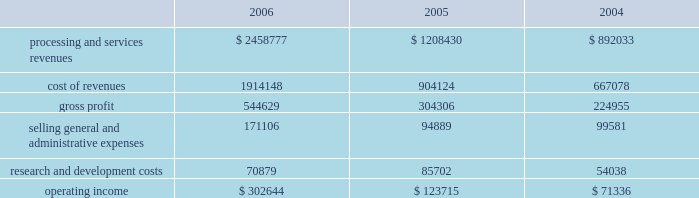Higher average borrowings .
Additionally , the recapitalization that occurred late in the first quarter of 2005 resulted in a full year of interest in 2006 as compared to approximately ten months in 2005 .
The increase in interest expense in 2005 as compared to 2004 also resulted from the recapitalization in 2005 .
Income tax expense income tax expense totaled $ 150.2 million , $ 116.1 million and $ 118.3 million for 2006 , 2005 and 2004 , respectively .
This resulted in an effective tax rate of 37.2% ( 37.2 % ) , 37.2% ( 37.2 % ) and 37.6% ( 37.6 % ) for 2006 , 2005 and 2004 , respectively .
Net earnings net earnings totaled $ 259.1 million , $ 196.6 and $ 189.4 million for 2006 , 2005 and 2004 , respectively , or $ 1.37 , $ 1.53 and $ 1.48 per diluted share , respectively .
Segment results of operations transaction processing services ( in thousands ) .
Revenues for the transaction processing services segment are derived from three main revenue channels ; enterprise solutions , integrated financial solutions and international .
Revenues from transaction processing services totaled $ 2458.8 million , $ 1208.4 and $ 892.0 million for 2006 , 2005 and 2004 , respectively .
The overall segment increase of $ 1250.4 million during 2006 , as compared to 2005 was primarily attributable to the certegy merger which contributed $ 1067.2 million to the overall increase .
The majority of the remaining 2006 growth is attributable to organic growth within the historically owned integrated financial solutions and international revenue channels , with international including $ 31.9 million related to the newly formed business process outsourcing operation in brazil .
The overall segment increase of $ 316.4 in 2005 as compared to 2004 results from the inclusion of a full year of results for the 2004 acquisitions of aurum , sanchez , kordoba , and intercept , which contributed $ 301.1 million of the increase .
Cost of revenues for the transaction processing services segment totaled $ 1914.1 million , $ 904.1 million and $ 667.1 million for 2006 , 2005 and 2004 , respectively .
The overall segment increase of $ 1010.0 million during 2006 as compared to 2005 was primarily attributable to the certegy merger which contributed $ 848.2 million to the increase .
Gross profit as a percentage of revenues ( 201cgross margin 201d ) was 22.2% ( 22.2 % ) , 25.2% ( 25.2 % ) and 25.2% ( 25.2 % ) for 2006 , 2005 and 2004 , respectively .
The decrease in gross profit in 2006 as compared to 2005 is primarily due to the february 1 , 2006 certegy merger , which businesses typically have lower margins than those of the historically owned fis businesses .
Incremental intangible asset amortization relating to the certegy merger also contributed to the decrease in gross margin .
Included in cost of revenues was depreciation and amortization of $ 272.4 million , $ 139.8 million , and $ 94.6 million for 2006 , 2005 and 2004 , respectively .
Selling , general and administrative expenses totaled $ 171.1 million , $ 94.9 million and $ 99.6 million for 2006 , 2005 and 2004 , respectively .
The increase in 2006 compared to 2005 is primarily attributable to the certegy merger which contributed $ 73.7 million to the overall increase of $ 76.2 million .
The decrease of $ 4.7 million in 2005 as compared to 2004 is primarily attributable to the effect of acquisition related costs in 2004 .
Included in selling , general and administrative expenses was depreciation and amortization of $ 11.0 million , $ 9.1 million and $ 2.3 million for 2006 , 2005 and 2004 , respectively. .
What was the percentage change in operating income from 2004 to 2005? 
Computations: ((123715 - 71336) / 71336)
Answer: 0.73426. 